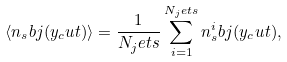Convert formula to latex. <formula><loc_0><loc_0><loc_500><loc_500>\langle n _ { s } b j ( y _ { c } u t ) \rangle = \frac { 1 } { N _ { j } e t s } \sum _ { i = 1 } ^ { N _ { j } e t s } n ^ { i } _ { s } b j ( y _ { c } u t ) ,</formula> 